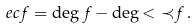Convert formula to latex. <formula><loc_0><loc_0><loc_500><loc_500>\ e c { f } = \deg { f } - \deg { < { \prec } { f } } \, .</formula> 